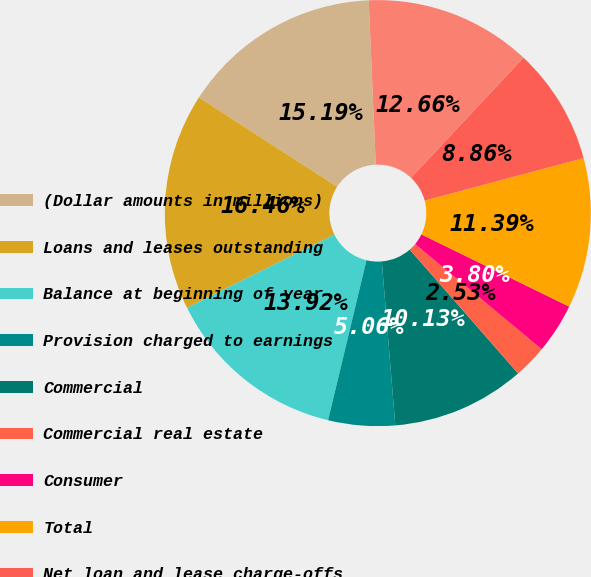Convert chart. <chart><loc_0><loc_0><loc_500><loc_500><pie_chart><fcel>(Dollar amounts in millions)<fcel>Loans and leases outstanding<fcel>Balance at beginning of year<fcel>Provision charged to earnings<fcel>Commercial<fcel>Commercial real estate<fcel>Consumer<fcel>Total<fcel>Net loan and lease charge-offs<fcel>Balance at end of year<nl><fcel>15.19%<fcel>16.46%<fcel>13.92%<fcel>5.06%<fcel>10.13%<fcel>2.53%<fcel>3.8%<fcel>11.39%<fcel>8.86%<fcel>12.66%<nl></chart> 